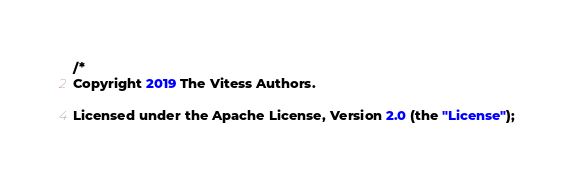<code> <loc_0><loc_0><loc_500><loc_500><_Go_>/*
Copyright 2019 The Vitess Authors.

Licensed under the Apache License, Version 2.0 (the "License");</code> 